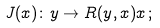Convert formula to latex. <formula><loc_0><loc_0><loc_500><loc_500>J ( x ) \colon y \rightarrow R ( y , x ) x \, ;</formula> 